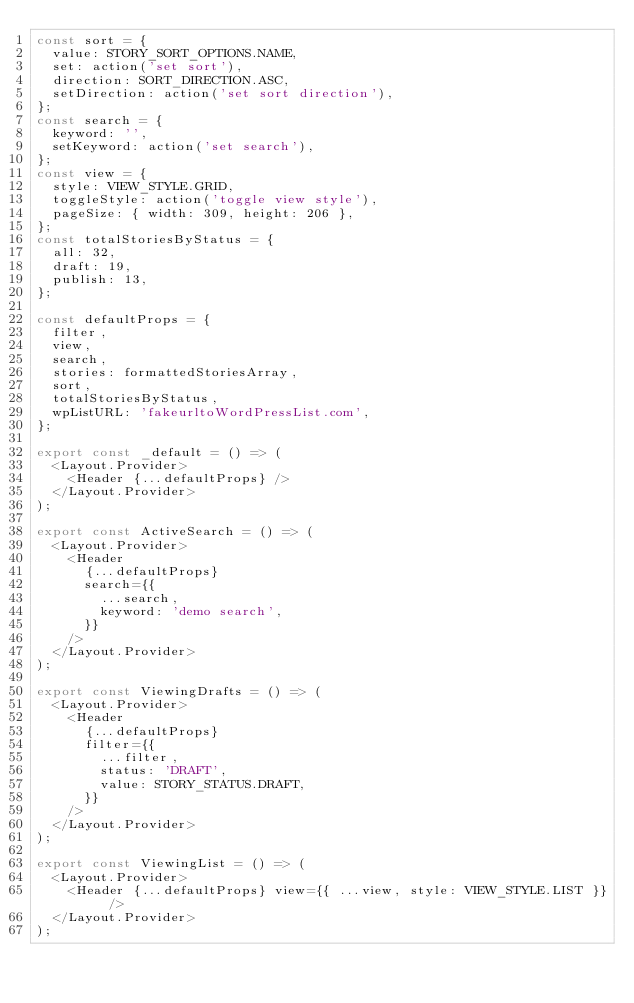Convert code to text. <code><loc_0><loc_0><loc_500><loc_500><_JavaScript_>const sort = {
  value: STORY_SORT_OPTIONS.NAME,
  set: action('set sort'),
  direction: SORT_DIRECTION.ASC,
  setDirection: action('set sort direction'),
};
const search = {
  keyword: '',
  setKeyword: action('set search'),
};
const view = {
  style: VIEW_STYLE.GRID,
  toggleStyle: action('toggle view style'),
  pageSize: { width: 309, height: 206 },
};
const totalStoriesByStatus = {
  all: 32,
  draft: 19,
  publish: 13,
};

const defaultProps = {
  filter,
  view,
  search,
  stories: formattedStoriesArray,
  sort,
  totalStoriesByStatus,
  wpListURL: 'fakeurltoWordPressList.com',
};

export const _default = () => (
  <Layout.Provider>
    <Header {...defaultProps} />
  </Layout.Provider>
);

export const ActiveSearch = () => (
  <Layout.Provider>
    <Header
      {...defaultProps}
      search={{
        ...search,
        keyword: 'demo search',
      }}
    />
  </Layout.Provider>
);

export const ViewingDrafts = () => (
  <Layout.Provider>
    <Header
      {...defaultProps}
      filter={{
        ...filter,
        status: 'DRAFT',
        value: STORY_STATUS.DRAFT,
      }}
    />
  </Layout.Provider>
);

export const ViewingList = () => (
  <Layout.Provider>
    <Header {...defaultProps} view={{ ...view, style: VIEW_STYLE.LIST }} />
  </Layout.Provider>
);
</code> 